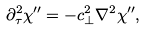<formula> <loc_0><loc_0><loc_500><loc_500>\partial _ { \tau } ^ { 2 } \chi ^ { \prime \prime } = - c _ { \perp } ^ { 2 } \nabla ^ { 2 } \chi ^ { \prime \prime } ,</formula> 